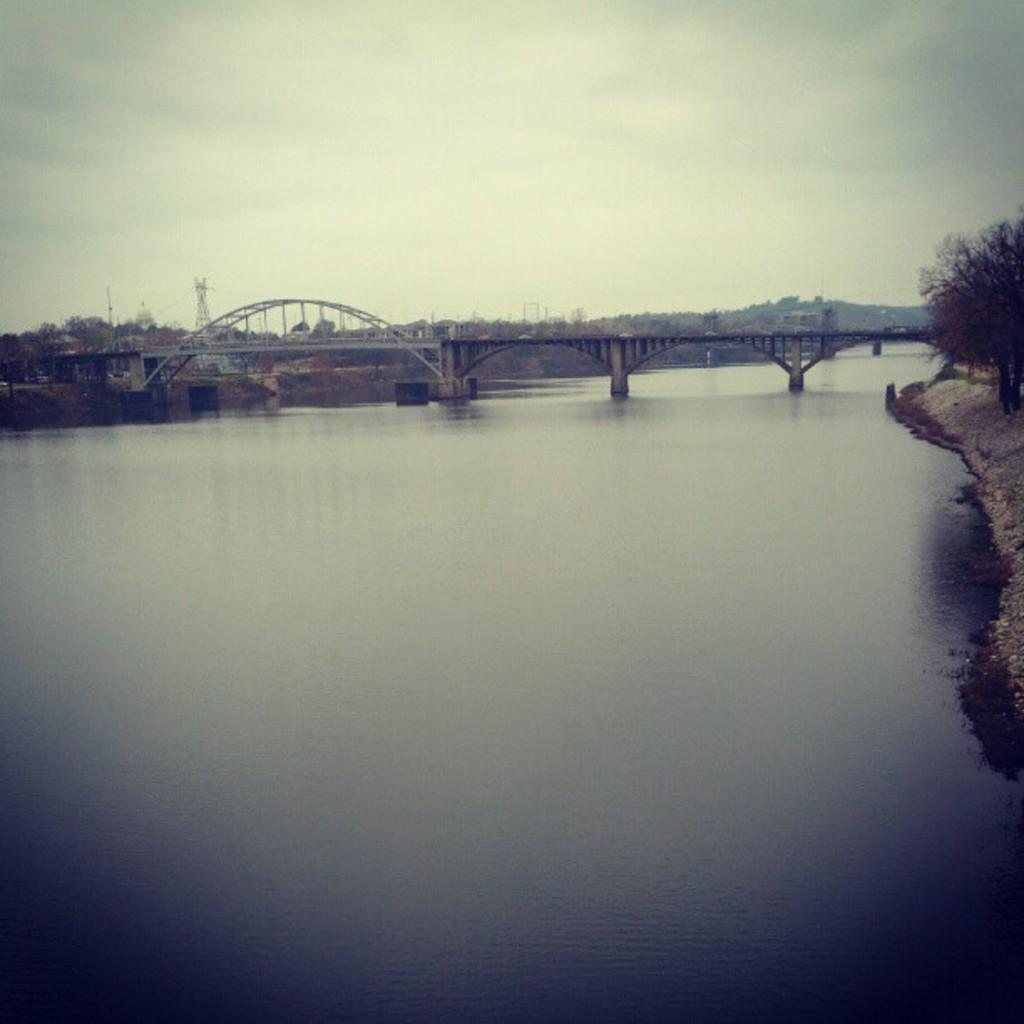In one or two sentences, can you explain what this image depicts? This is an outside view. At the bottom of this image there is a sea. In the middle of the image there is a bridge. On the right and left side of the image there are trees. At the top of the image I can see the sky. 